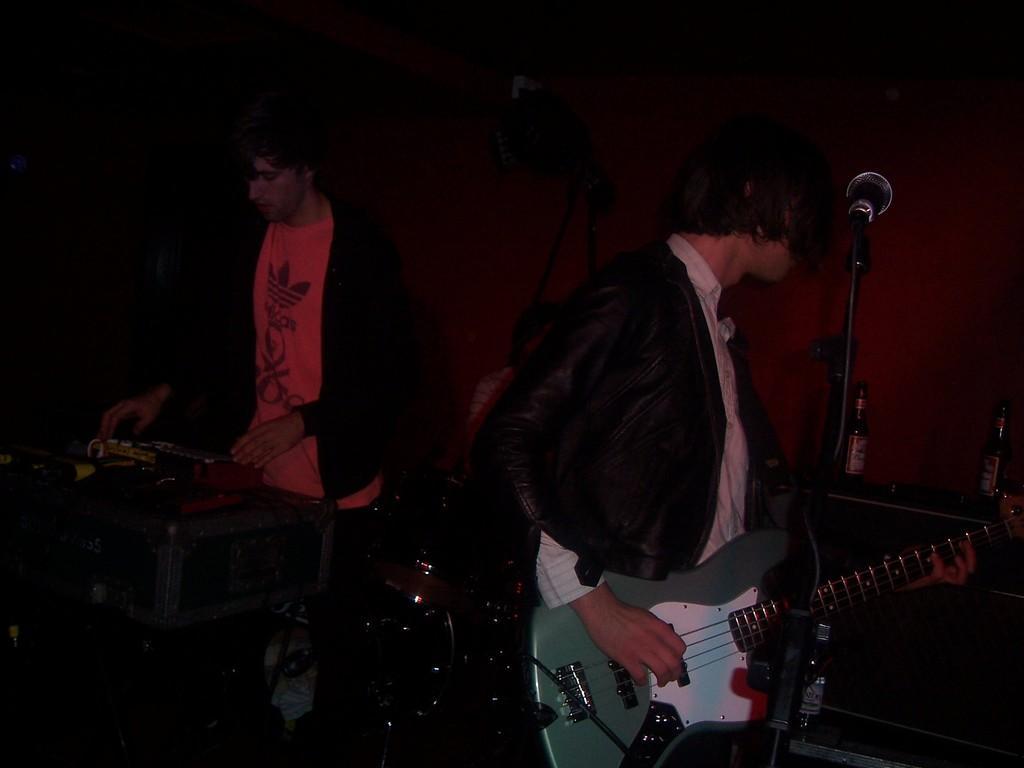Please provide a concise description of this image. In this image in the center there are musicians performing and there are musical instruments. In the background there are bottles and in the center there is a mic and in the background there is a wall. 